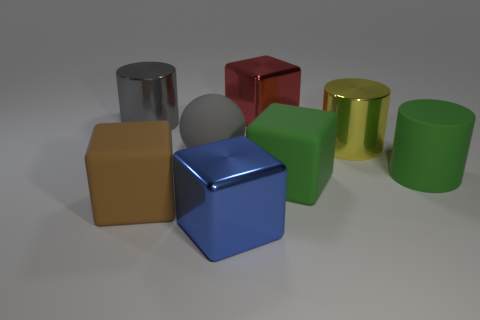What colors are the objects in the image? The objects in the image include a range of colors: there is a red cube, a blue cube, a yellow cylinder, a green cylinder, a grey cube, a silver cylinder, and a brown cube. 